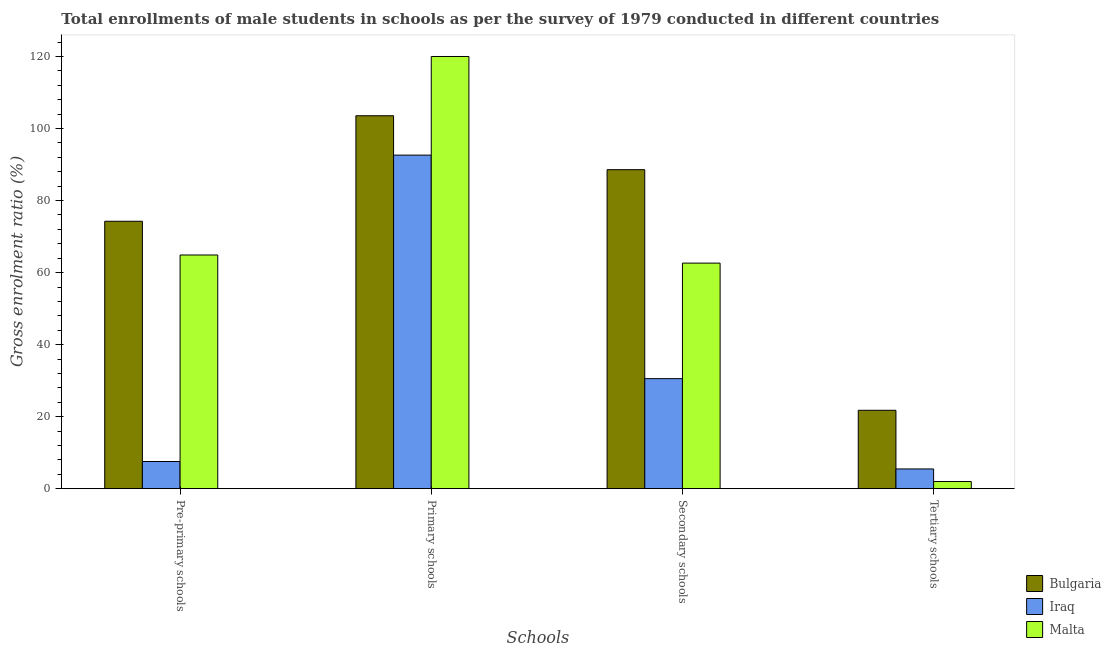How many groups of bars are there?
Provide a short and direct response. 4. Are the number of bars per tick equal to the number of legend labels?
Give a very brief answer. Yes. Are the number of bars on each tick of the X-axis equal?
Your response must be concise. Yes. How many bars are there on the 3rd tick from the left?
Provide a succinct answer. 3. What is the label of the 2nd group of bars from the left?
Give a very brief answer. Primary schools. What is the gross enrolment ratio(male) in pre-primary schools in Malta?
Your answer should be compact. 64.89. Across all countries, what is the maximum gross enrolment ratio(male) in tertiary schools?
Give a very brief answer. 21.77. Across all countries, what is the minimum gross enrolment ratio(male) in primary schools?
Your answer should be very brief. 92.63. In which country was the gross enrolment ratio(male) in pre-primary schools maximum?
Provide a succinct answer. Bulgaria. In which country was the gross enrolment ratio(male) in pre-primary schools minimum?
Keep it short and to the point. Iraq. What is the total gross enrolment ratio(male) in tertiary schools in the graph?
Offer a very short reply. 29.23. What is the difference between the gross enrolment ratio(male) in secondary schools in Malta and that in Bulgaria?
Keep it short and to the point. -25.95. What is the difference between the gross enrolment ratio(male) in primary schools in Iraq and the gross enrolment ratio(male) in pre-primary schools in Malta?
Give a very brief answer. 27.73. What is the average gross enrolment ratio(male) in secondary schools per country?
Give a very brief answer. 60.59. What is the difference between the gross enrolment ratio(male) in tertiary schools and gross enrolment ratio(male) in secondary schools in Iraq?
Give a very brief answer. -25.08. In how many countries, is the gross enrolment ratio(male) in pre-primary schools greater than 52 %?
Offer a terse response. 2. What is the ratio of the gross enrolment ratio(male) in primary schools in Bulgaria to that in Iraq?
Offer a very short reply. 1.12. Is the gross enrolment ratio(male) in pre-primary schools in Malta less than that in Bulgaria?
Your answer should be very brief. Yes. Is the difference between the gross enrolment ratio(male) in secondary schools in Iraq and Malta greater than the difference between the gross enrolment ratio(male) in tertiary schools in Iraq and Malta?
Keep it short and to the point. No. What is the difference between the highest and the second highest gross enrolment ratio(male) in primary schools?
Offer a very short reply. 16.46. What is the difference between the highest and the lowest gross enrolment ratio(male) in pre-primary schools?
Offer a very short reply. 66.71. What does the 3rd bar from the left in Pre-primary schools represents?
Offer a terse response. Malta. What does the 1st bar from the right in Pre-primary schools represents?
Give a very brief answer. Malta. Are all the bars in the graph horizontal?
Offer a very short reply. No. How many countries are there in the graph?
Your response must be concise. 3. Does the graph contain grids?
Your answer should be very brief. No. How many legend labels are there?
Provide a succinct answer. 3. What is the title of the graph?
Give a very brief answer. Total enrollments of male students in schools as per the survey of 1979 conducted in different countries. Does "Greece" appear as one of the legend labels in the graph?
Offer a very short reply. No. What is the label or title of the X-axis?
Provide a succinct answer. Schools. What is the Gross enrolment ratio (%) in Bulgaria in Pre-primary schools?
Offer a terse response. 74.25. What is the Gross enrolment ratio (%) in Iraq in Pre-primary schools?
Give a very brief answer. 7.54. What is the Gross enrolment ratio (%) of Malta in Pre-primary schools?
Keep it short and to the point. 64.89. What is the Gross enrolment ratio (%) in Bulgaria in Primary schools?
Keep it short and to the point. 103.56. What is the Gross enrolment ratio (%) of Iraq in Primary schools?
Provide a short and direct response. 92.63. What is the Gross enrolment ratio (%) of Malta in Primary schools?
Your answer should be compact. 120.02. What is the Gross enrolment ratio (%) in Bulgaria in Secondary schools?
Offer a terse response. 88.58. What is the Gross enrolment ratio (%) in Iraq in Secondary schools?
Your response must be concise. 30.55. What is the Gross enrolment ratio (%) of Malta in Secondary schools?
Provide a succinct answer. 62.64. What is the Gross enrolment ratio (%) in Bulgaria in Tertiary schools?
Give a very brief answer. 21.77. What is the Gross enrolment ratio (%) in Iraq in Tertiary schools?
Offer a terse response. 5.48. What is the Gross enrolment ratio (%) in Malta in Tertiary schools?
Your answer should be very brief. 1.99. Across all Schools, what is the maximum Gross enrolment ratio (%) of Bulgaria?
Give a very brief answer. 103.56. Across all Schools, what is the maximum Gross enrolment ratio (%) of Iraq?
Make the answer very short. 92.63. Across all Schools, what is the maximum Gross enrolment ratio (%) in Malta?
Make the answer very short. 120.02. Across all Schools, what is the minimum Gross enrolment ratio (%) of Bulgaria?
Make the answer very short. 21.77. Across all Schools, what is the minimum Gross enrolment ratio (%) in Iraq?
Keep it short and to the point. 5.48. Across all Schools, what is the minimum Gross enrolment ratio (%) of Malta?
Your response must be concise. 1.99. What is the total Gross enrolment ratio (%) of Bulgaria in the graph?
Provide a succinct answer. 288.16. What is the total Gross enrolment ratio (%) in Iraq in the graph?
Your answer should be compact. 136.2. What is the total Gross enrolment ratio (%) in Malta in the graph?
Offer a terse response. 249.53. What is the difference between the Gross enrolment ratio (%) of Bulgaria in Pre-primary schools and that in Primary schools?
Provide a short and direct response. -29.3. What is the difference between the Gross enrolment ratio (%) of Iraq in Pre-primary schools and that in Primary schools?
Ensure brevity in your answer.  -85.08. What is the difference between the Gross enrolment ratio (%) in Malta in Pre-primary schools and that in Primary schools?
Your answer should be compact. -55.12. What is the difference between the Gross enrolment ratio (%) in Bulgaria in Pre-primary schools and that in Secondary schools?
Offer a very short reply. -14.33. What is the difference between the Gross enrolment ratio (%) in Iraq in Pre-primary schools and that in Secondary schools?
Your response must be concise. -23.01. What is the difference between the Gross enrolment ratio (%) in Malta in Pre-primary schools and that in Secondary schools?
Give a very brief answer. 2.26. What is the difference between the Gross enrolment ratio (%) of Bulgaria in Pre-primary schools and that in Tertiary schools?
Provide a succinct answer. 52.49. What is the difference between the Gross enrolment ratio (%) of Iraq in Pre-primary schools and that in Tertiary schools?
Ensure brevity in your answer.  2.06. What is the difference between the Gross enrolment ratio (%) of Malta in Pre-primary schools and that in Tertiary schools?
Offer a very short reply. 62.91. What is the difference between the Gross enrolment ratio (%) of Bulgaria in Primary schools and that in Secondary schools?
Provide a short and direct response. 14.98. What is the difference between the Gross enrolment ratio (%) of Iraq in Primary schools and that in Secondary schools?
Your answer should be compact. 62.07. What is the difference between the Gross enrolment ratio (%) in Malta in Primary schools and that in Secondary schools?
Your answer should be compact. 57.38. What is the difference between the Gross enrolment ratio (%) of Bulgaria in Primary schools and that in Tertiary schools?
Your answer should be compact. 81.79. What is the difference between the Gross enrolment ratio (%) of Iraq in Primary schools and that in Tertiary schools?
Your answer should be compact. 87.15. What is the difference between the Gross enrolment ratio (%) in Malta in Primary schools and that in Tertiary schools?
Offer a terse response. 118.03. What is the difference between the Gross enrolment ratio (%) in Bulgaria in Secondary schools and that in Tertiary schools?
Offer a terse response. 66.82. What is the difference between the Gross enrolment ratio (%) of Iraq in Secondary schools and that in Tertiary schools?
Your answer should be compact. 25.08. What is the difference between the Gross enrolment ratio (%) of Malta in Secondary schools and that in Tertiary schools?
Provide a succinct answer. 60.65. What is the difference between the Gross enrolment ratio (%) in Bulgaria in Pre-primary schools and the Gross enrolment ratio (%) in Iraq in Primary schools?
Give a very brief answer. -18.37. What is the difference between the Gross enrolment ratio (%) of Bulgaria in Pre-primary schools and the Gross enrolment ratio (%) of Malta in Primary schools?
Your response must be concise. -45.76. What is the difference between the Gross enrolment ratio (%) of Iraq in Pre-primary schools and the Gross enrolment ratio (%) of Malta in Primary schools?
Ensure brevity in your answer.  -112.47. What is the difference between the Gross enrolment ratio (%) of Bulgaria in Pre-primary schools and the Gross enrolment ratio (%) of Iraq in Secondary schools?
Your answer should be compact. 43.7. What is the difference between the Gross enrolment ratio (%) in Bulgaria in Pre-primary schools and the Gross enrolment ratio (%) in Malta in Secondary schools?
Ensure brevity in your answer.  11.62. What is the difference between the Gross enrolment ratio (%) of Iraq in Pre-primary schools and the Gross enrolment ratio (%) of Malta in Secondary schools?
Give a very brief answer. -55.09. What is the difference between the Gross enrolment ratio (%) of Bulgaria in Pre-primary schools and the Gross enrolment ratio (%) of Iraq in Tertiary schools?
Make the answer very short. 68.78. What is the difference between the Gross enrolment ratio (%) in Bulgaria in Pre-primary schools and the Gross enrolment ratio (%) in Malta in Tertiary schools?
Your answer should be very brief. 72.27. What is the difference between the Gross enrolment ratio (%) in Iraq in Pre-primary schools and the Gross enrolment ratio (%) in Malta in Tertiary schools?
Make the answer very short. 5.56. What is the difference between the Gross enrolment ratio (%) of Bulgaria in Primary schools and the Gross enrolment ratio (%) of Iraq in Secondary schools?
Offer a very short reply. 73. What is the difference between the Gross enrolment ratio (%) of Bulgaria in Primary schools and the Gross enrolment ratio (%) of Malta in Secondary schools?
Your answer should be compact. 40.92. What is the difference between the Gross enrolment ratio (%) in Iraq in Primary schools and the Gross enrolment ratio (%) in Malta in Secondary schools?
Offer a very short reply. 29.99. What is the difference between the Gross enrolment ratio (%) in Bulgaria in Primary schools and the Gross enrolment ratio (%) in Iraq in Tertiary schools?
Keep it short and to the point. 98.08. What is the difference between the Gross enrolment ratio (%) of Bulgaria in Primary schools and the Gross enrolment ratio (%) of Malta in Tertiary schools?
Offer a very short reply. 101.57. What is the difference between the Gross enrolment ratio (%) in Iraq in Primary schools and the Gross enrolment ratio (%) in Malta in Tertiary schools?
Ensure brevity in your answer.  90.64. What is the difference between the Gross enrolment ratio (%) of Bulgaria in Secondary schools and the Gross enrolment ratio (%) of Iraq in Tertiary schools?
Your response must be concise. 83.1. What is the difference between the Gross enrolment ratio (%) in Bulgaria in Secondary schools and the Gross enrolment ratio (%) in Malta in Tertiary schools?
Give a very brief answer. 86.6. What is the difference between the Gross enrolment ratio (%) of Iraq in Secondary schools and the Gross enrolment ratio (%) of Malta in Tertiary schools?
Ensure brevity in your answer.  28.57. What is the average Gross enrolment ratio (%) in Bulgaria per Schools?
Provide a short and direct response. 72.04. What is the average Gross enrolment ratio (%) of Iraq per Schools?
Ensure brevity in your answer.  34.05. What is the average Gross enrolment ratio (%) in Malta per Schools?
Provide a short and direct response. 62.38. What is the difference between the Gross enrolment ratio (%) in Bulgaria and Gross enrolment ratio (%) in Iraq in Pre-primary schools?
Make the answer very short. 66.71. What is the difference between the Gross enrolment ratio (%) of Bulgaria and Gross enrolment ratio (%) of Malta in Pre-primary schools?
Ensure brevity in your answer.  9.36. What is the difference between the Gross enrolment ratio (%) of Iraq and Gross enrolment ratio (%) of Malta in Pre-primary schools?
Offer a very short reply. -57.35. What is the difference between the Gross enrolment ratio (%) of Bulgaria and Gross enrolment ratio (%) of Iraq in Primary schools?
Make the answer very short. 10.93. What is the difference between the Gross enrolment ratio (%) of Bulgaria and Gross enrolment ratio (%) of Malta in Primary schools?
Make the answer very short. -16.46. What is the difference between the Gross enrolment ratio (%) of Iraq and Gross enrolment ratio (%) of Malta in Primary schools?
Your answer should be very brief. -27.39. What is the difference between the Gross enrolment ratio (%) of Bulgaria and Gross enrolment ratio (%) of Iraq in Secondary schools?
Your answer should be very brief. 58.03. What is the difference between the Gross enrolment ratio (%) of Bulgaria and Gross enrolment ratio (%) of Malta in Secondary schools?
Your answer should be very brief. 25.95. What is the difference between the Gross enrolment ratio (%) of Iraq and Gross enrolment ratio (%) of Malta in Secondary schools?
Your response must be concise. -32.08. What is the difference between the Gross enrolment ratio (%) of Bulgaria and Gross enrolment ratio (%) of Iraq in Tertiary schools?
Make the answer very short. 16.29. What is the difference between the Gross enrolment ratio (%) in Bulgaria and Gross enrolment ratio (%) in Malta in Tertiary schools?
Offer a terse response. 19.78. What is the difference between the Gross enrolment ratio (%) in Iraq and Gross enrolment ratio (%) in Malta in Tertiary schools?
Ensure brevity in your answer.  3.49. What is the ratio of the Gross enrolment ratio (%) of Bulgaria in Pre-primary schools to that in Primary schools?
Your answer should be very brief. 0.72. What is the ratio of the Gross enrolment ratio (%) in Iraq in Pre-primary schools to that in Primary schools?
Your response must be concise. 0.08. What is the ratio of the Gross enrolment ratio (%) in Malta in Pre-primary schools to that in Primary schools?
Your answer should be very brief. 0.54. What is the ratio of the Gross enrolment ratio (%) in Bulgaria in Pre-primary schools to that in Secondary schools?
Provide a short and direct response. 0.84. What is the ratio of the Gross enrolment ratio (%) in Iraq in Pre-primary schools to that in Secondary schools?
Your response must be concise. 0.25. What is the ratio of the Gross enrolment ratio (%) of Malta in Pre-primary schools to that in Secondary schools?
Give a very brief answer. 1.04. What is the ratio of the Gross enrolment ratio (%) in Bulgaria in Pre-primary schools to that in Tertiary schools?
Your answer should be very brief. 3.41. What is the ratio of the Gross enrolment ratio (%) in Iraq in Pre-primary schools to that in Tertiary schools?
Offer a terse response. 1.38. What is the ratio of the Gross enrolment ratio (%) of Malta in Pre-primary schools to that in Tertiary schools?
Ensure brevity in your answer.  32.68. What is the ratio of the Gross enrolment ratio (%) in Bulgaria in Primary schools to that in Secondary schools?
Make the answer very short. 1.17. What is the ratio of the Gross enrolment ratio (%) in Iraq in Primary schools to that in Secondary schools?
Offer a very short reply. 3.03. What is the ratio of the Gross enrolment ratio (%) in Malta in Primary schools to that in Secondary schools?
Make the answer very short. 1.92. What is the ratio of the Gross enrolment ratio (%) of Bulgaria in Primary schools to that in Tertiary schools?
Keep it short and to the point. 4.76. What is the ratio of the Gross enrolment ratio (%) in Iraq in Primary schools to that in Tertiary schools?
Provide a succinct answer. 16.91. What is the ratio of the Gross enrolment ratio (%) in Malta in Primary schools to that in Tertiary schools?
Give a very brief answer. 60.45. What is the ratio of the Gross enrolment ratio (%) of Bulgaria in Secondary schools to that in Tertiary schools?
Your answer should be very brief. 4.07. What is the ratio of the Gross enrolment ratio (%) in Iraq in Secondary schools to that in Tertiary schools?
Offer a terse response. 5.58. What is the ratio of the Gross enrolment ratio (%) in Malta in Secondary schools to that in Tertiary schools?
Give a very brief answer. 31.55. What is the difference between the highest and the second highest Gross enrolment ratio (%) in Bulgaria?
Offer a terse response. 14.98. What is the difference between the highest and the second highest Gross enrolment ratio (%) of Iraq?
Offer a terse response. 62.07. What is the difference between the highest and the second highest Gross enrolment ratio (%) in Malta?
Your answer should be very brief. 55.12. What is the difference between the highest and the lowest Gross enrolment ratio (%) of Bulgaria?
Your response must be concise. 81.79. What is the difference between the highest and the lowest Gross enrolment ratio (%) in Iraq?
Your answer should be compact. 87.15. What is the difference between the highest and the lowest Gross enrolment ratio (%) in Malta?
Keep it short and to the point. 118.03. 